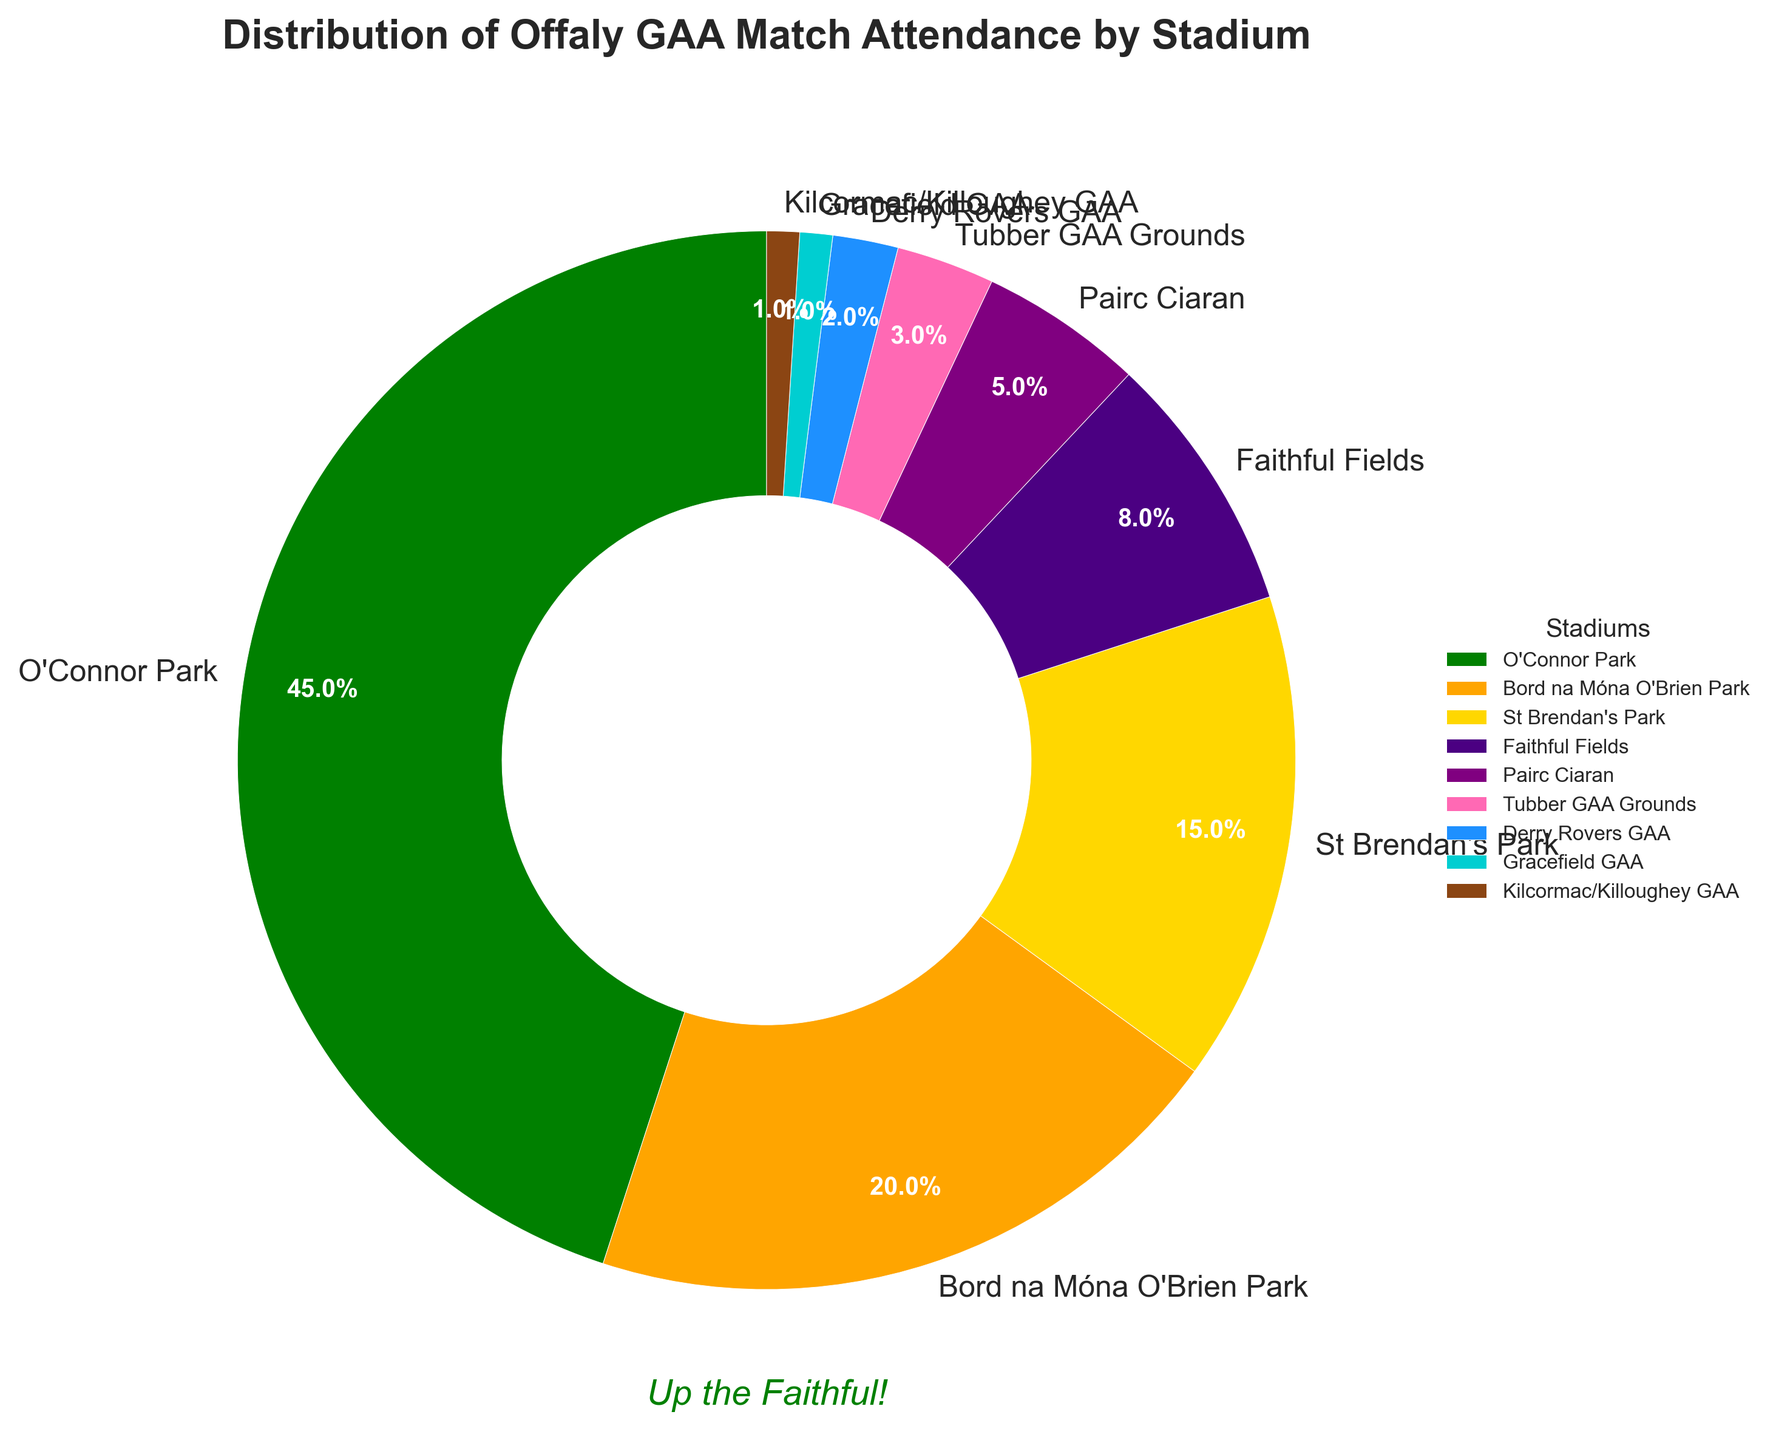What's the percentage of match attendance at O'Connor Park? The pie chart shows a slice labeled "O'Connor Park," and the corresponding percentage labeled on the slice is 45%.
Answer: 45% Which stadium has the smallest percentage of match attendance? According to the pie chart, the slices for "Kilcormac/Killoughey GAA" and "Gracefield GAA" are the smallest and are both labeled 1%.
Answer: Kilcormac/Killoughey GAA and Gracefield GAA How much more attendance does O'Connor Park have compared to Bord na Móna O'Brien Park? The percentage of attendance for O'Connor Park is 45%, and for Bord na Móna O'Brien Park, it is 20%. Subtract the latter from the former to get 45% - 20% = 25%.
Answer: 25% Which stadiums collectively make up more than half of the attendance? The stadiums listed with their percentages are: O'Connor Park (45%), Bord na Móna O'Brien Park (20%), and St Brendan's Park (15%). Adding them up: 45% + 20% + 15% = 80%, which is more than half.
Answer: O'Connor Park, Bord na Móna O'Brien Park, and St Brendan's Park What's the visual attribute of Faithful Fields compared to Pairc Ciaran? The slice for Faithful Fields is larger than the slice for Pairc Ciaran. Faithful Fields has an 8% label, while Pairc Ciaran has a 5% label.
Answer: Larger slice for Faithful Fields How does the attendance at the top two stadiums compare to the rest combined? The top two stadiums are O'Connor Park (45%) and Bord na Móna O'Brien Park (20%), adding up to 65%. The remaining stadiums add up to 35% (100% - 45% - 20%).
Answer: 65% (top two) vs. 35% (rest) What percentage of match attendance is at stadiums with less than 10% each? The stadiums with less than 10% are Faithful Fields (8%), Pairc Ciaran (5%), Tubber GAA Grounds (3%), Derry Rovers GAA (2%), Gracefield GAA (1%), and Kilcormac/Killoughey GAA (1%). Adding them: 8% + 5% + 3% + 2% + 1% + 1% = 20%.
Answer: 20% Are there more stadiums with less than 5% attendance or more? The stadiums with less than 5% attendance are Tubber GAA Grounds (3%), Derry Rovers GAA (2%), Gracefield GAA (1%), and Kilcormac/Killoughey GAA (1%), adding up to 4 stadiums. The ones with 5% or more are O'Connor Park (45%), Bord na Móna O'Brien Park (20%), St Brendan's Park (15%), Faithful Fields (8%), and Pairc Ciaran (5%), adding up to 5 stadiums.
Answer: More stadiums with 5% or more How would you describe the color used for Bord na Móna O'Brien Park in the pie chart? The slice for Bord na Móna O'Brien Park is represented using an orange color in the pie chart.
Answer: Orange 